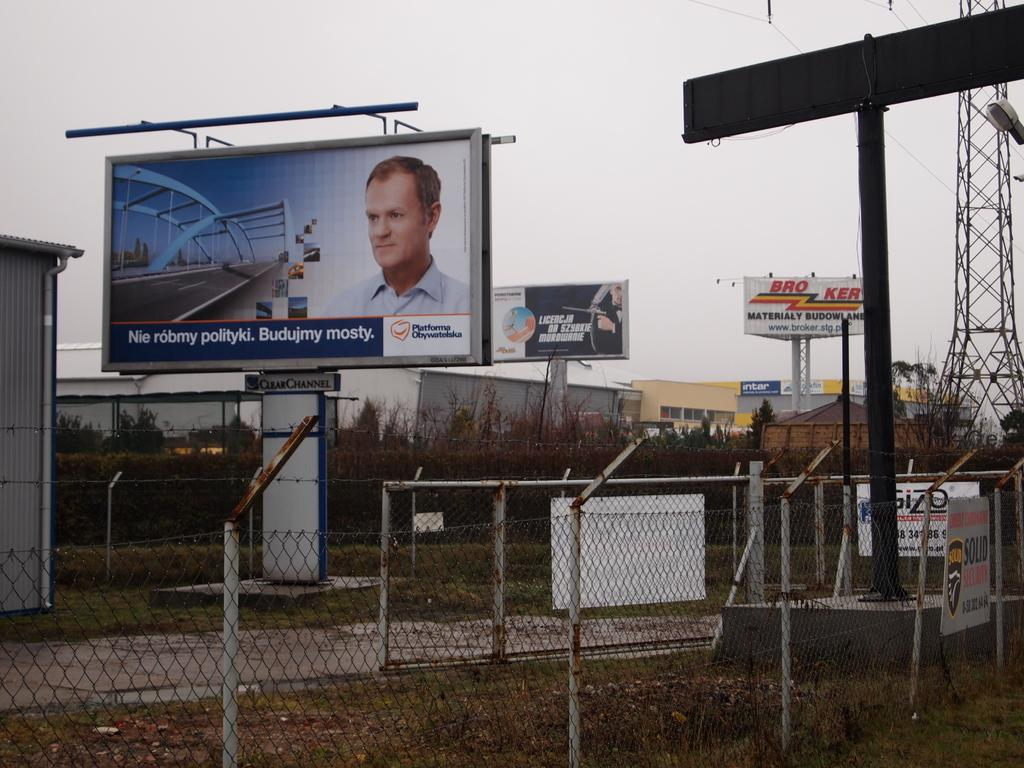<image>
Render a clear and concise summary of the photo. A billboard saying Nie romby polity. Budujmy with other billboards in an industrial area. 